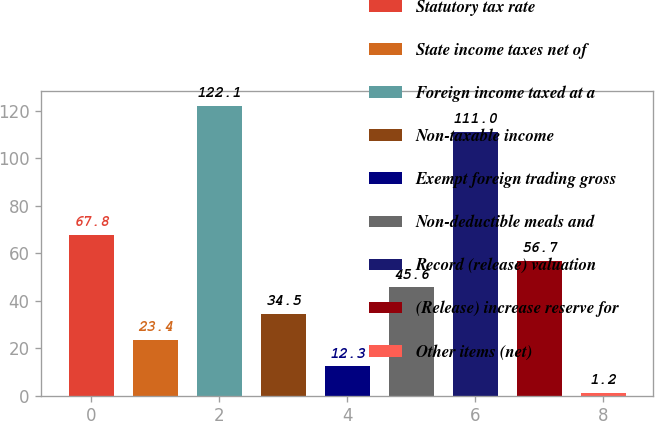Convert chart. <chart><loc_0><loc_0><loc_500><loc_500><bar_chart><fcel>Statutory tax rate<fcel>State income taxes net of<fcel>Foreign income taxed at a<fcel>Non-taxable income<fcel>Exempt foreign trading gross<fcel>Non-deductible meals and<fcel>Record (release) valuation<fcel>(Release) increase reserve for<fcel>Other items (net)<nl><fcel>67.8<fcel>23.4<fcel>122.1<fcel>34.5<fcel>12.3<fcel>45.6<fcel>111<fcel>56.7<fcel>1.2<nl></chart> 